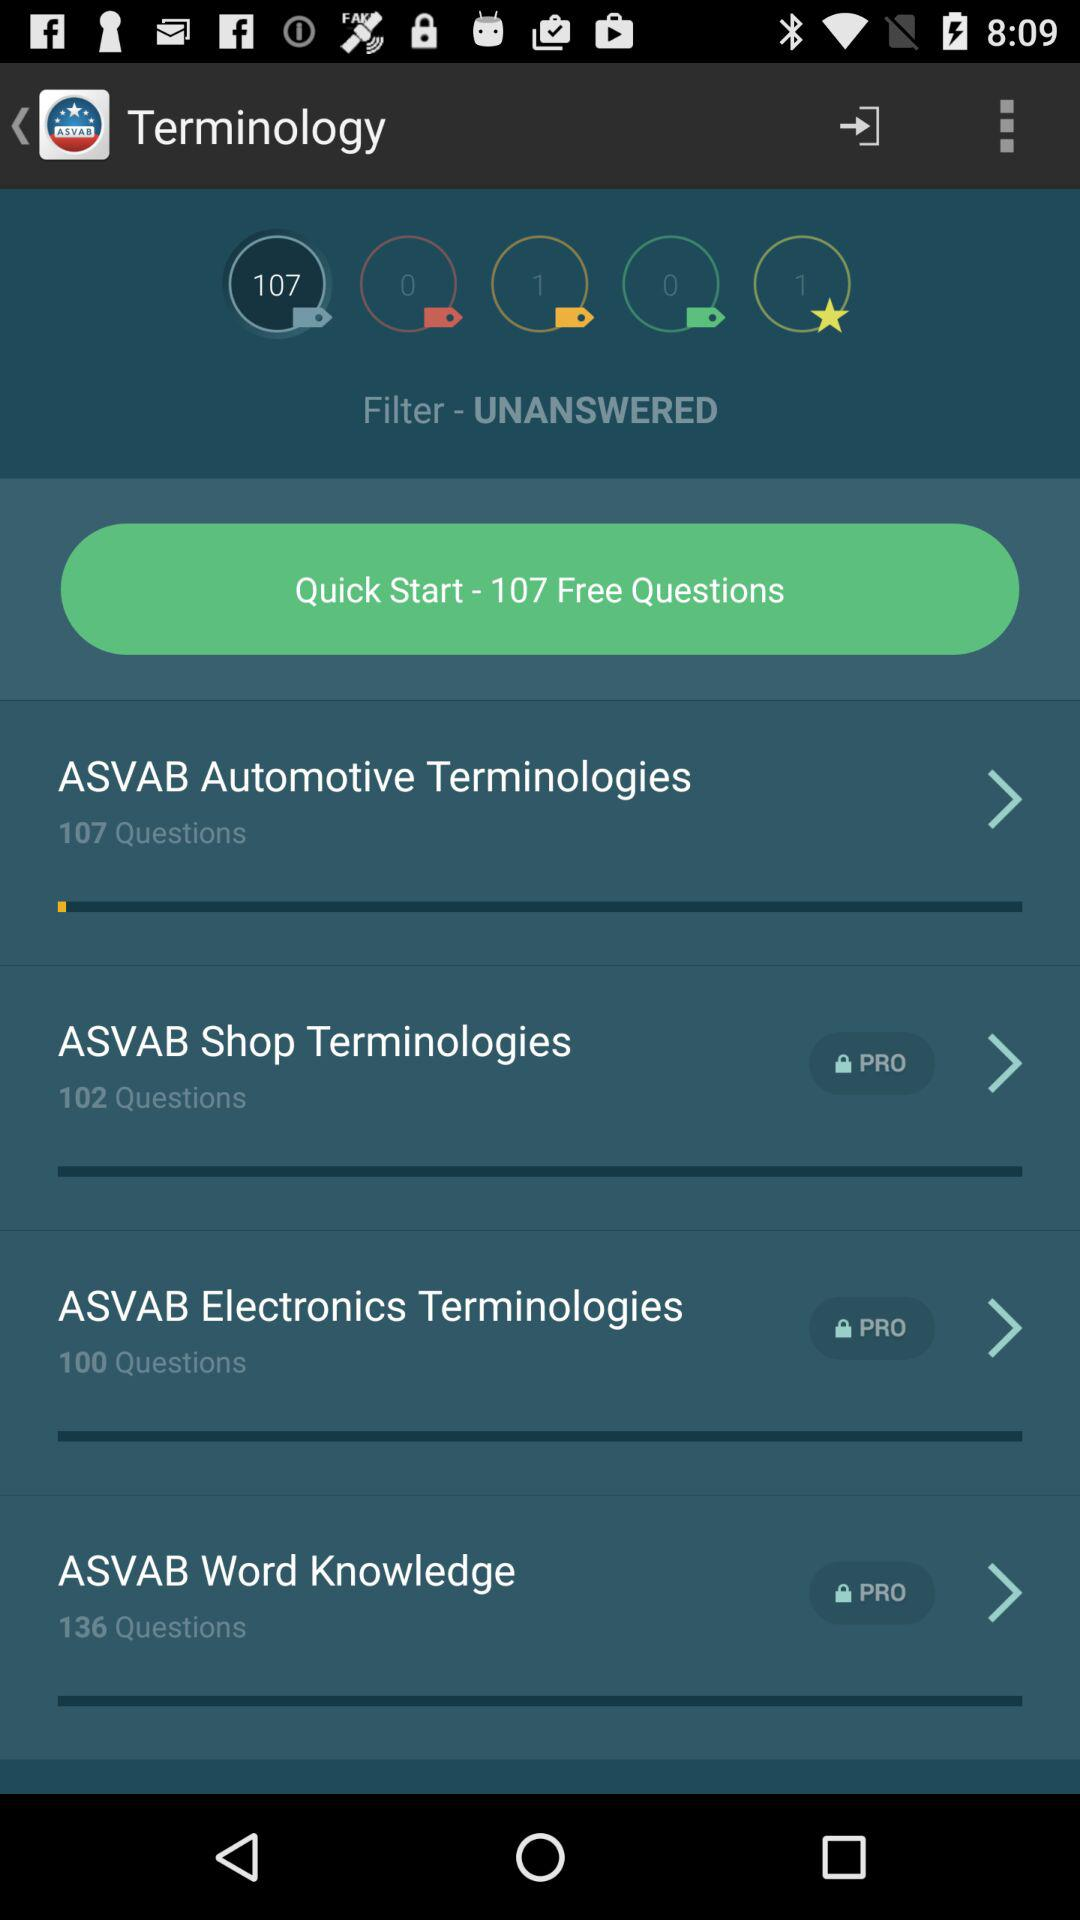How many questions are there in "ASVAB Shop Terminologies"? There are 102 questions in "ASVAB Shop Terminologies". 